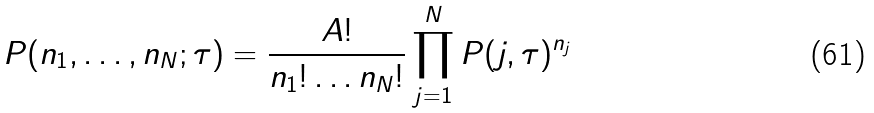<formula> <loc_0><loc_0><loc_500><loc_500>P ( n _ { 1 } , \dots , n _ { N } ; \tau ) = \frac { A ! } { n _ { 1 } ! \dots n _ { N } ! } \prod _ { j = 1 } ^ { N } P ( j , \tau ) ^ { n _ { j } }</formula> 